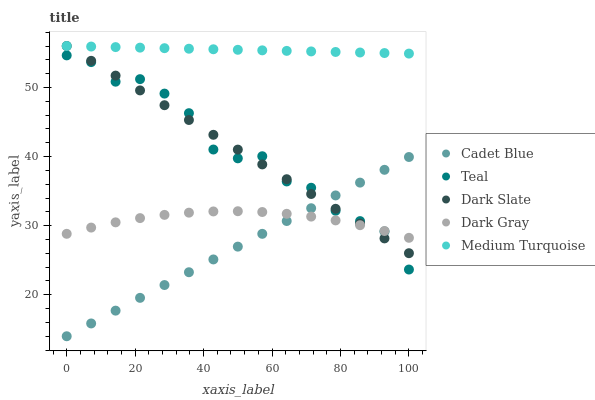Does Cadet Blue have the minimum area under the curve?
Answer yes or no. Yes. Does Medium Turquoise have the maximum area under the curve?
Answer yes or no. Yes. Does Dark Slate have the minimum area under the curve?
Answer yes or no. No. Does Dark Slate have the maximum area under the curve?
Answer yes or no. No. Is Cadet Blue the smoothest?
Answer yes or no. Yes. Is Teal the roughest?
Answer yes or no. Yes. Is Dark Slate the smoothest?
Answer yes or no. No. Is Dark Slate the roughest?
Answer yes or no. No. Does Cadet Blue have the lowest value?
Answer yes or no. Yes. Does Dark Slate have the lowest value?
Answer yes or no. No. Does Medium Turquoise have the highest value?
Answer yes or no. Yes. Does Cadet Blue have the highest value?
Answer yes or no. No. Is Cadet Blue less than Medium Turquoise?
Answer yes or no. Yes. Is Medium Turquoise greater than Dark Gray?
Answer yes or no. Yes. Does Cadet Blue intersect Dark Slate?
Answer yes or no. Yes. Is Cadet Blue less than Dark Slate?
Answer yes or no. No. Is Cadet Blue greater than Dark Slate?
Answer yes or no. No. Does Cadet Blue intersect Medium Turquoise?
Answer yes or no. No. 